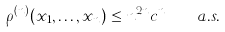Convert formula to latex. <formula><loc_0><loc_0><loc_500><loc_500>\rho ^ { ( n ) } ( x _ { 1 } , \dots , x _ { n } ) \leq n ^ { 2 n } c ^ { n } \quad a . s .</formula> 